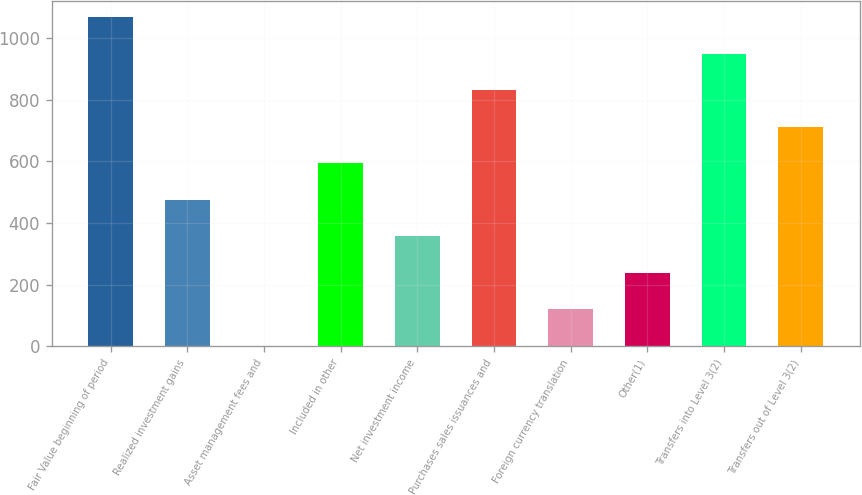Convert chart. <chart><loc_0><loc_0><loc_500><loc_500><bar_chart><fcel>Fair Value beginning of period<fcel>Realized investment gains<fcel>Asset management fees and<fcel>Included in other<fcel>Net investment income<fcel>Purchases sales issuances and<fcel>Foreign currency translation<fcel>Other(1)<fcel>Transfers into Level 3(2)<fcel>Transfers out of Level 3(2)<nl><fcel>1068.45<fcel>475.5<fcel>1.14<fcel>594.09<fcel>356.91<fcel>831.27<fcel>119.73<fcel>238.32<fcel>949.86<fcel>712.68<nl></chart> 